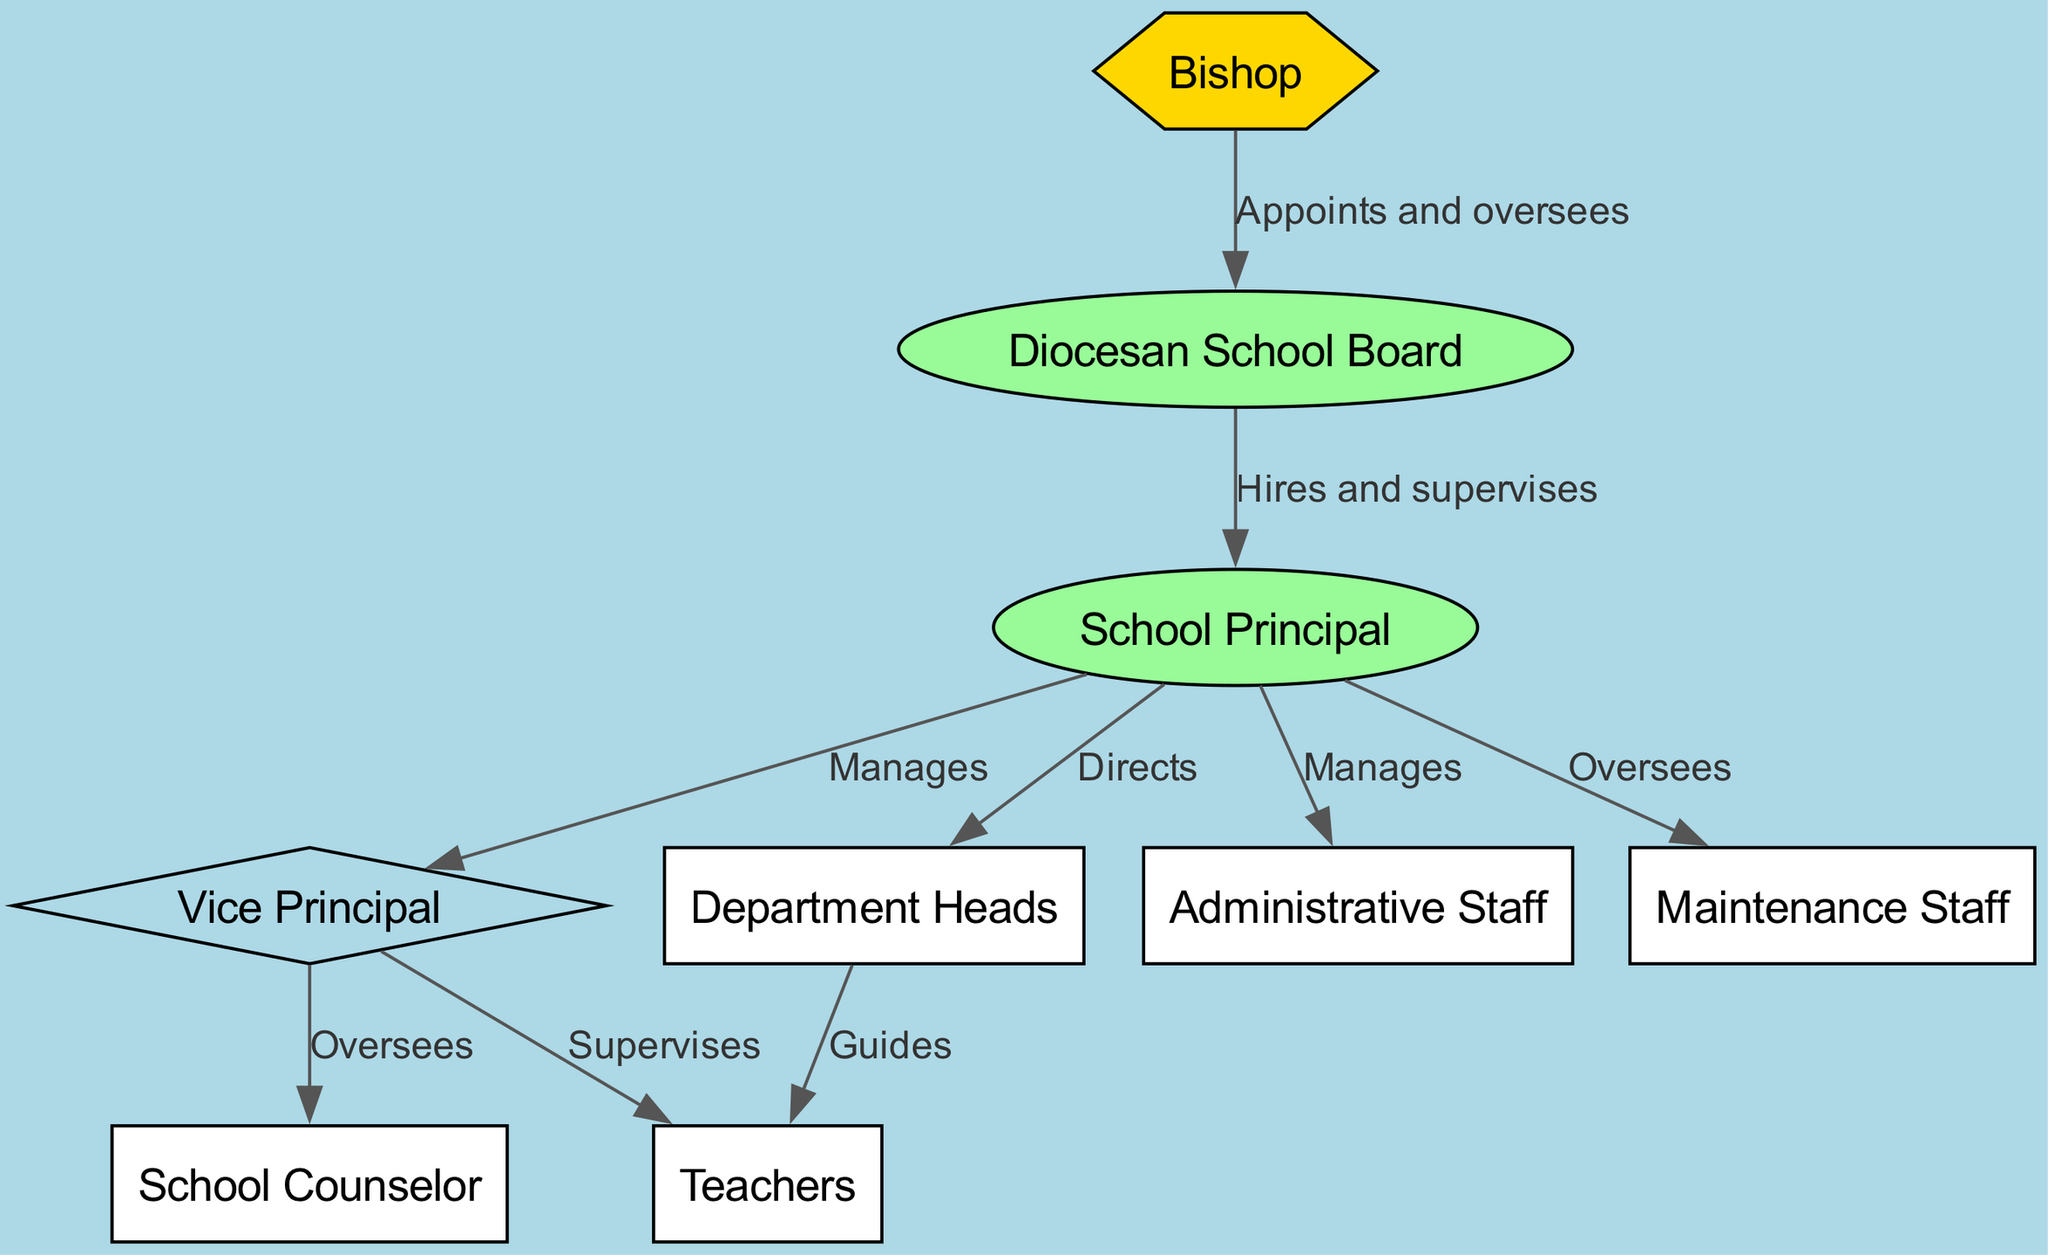What is the top node in the hierarchy? The diagram shows "Bishop" at the top, indicating that the Bishop is the highest authority in the structure. Therefore, "Bishop" is the top node in the hierarchy.
Answer: Bishop How many nodes are present in the diagram? By counting the distinct positions shown, there are a total of 9 unique nodes representing various roles within the Catholic school system. Thus, the answer is 9.
Answer: 9 Who does the Vice Principal supervise? The edges from "Vice Principal" show arrows leading to both "Teachers" and "School Counselor". This means the Vice Principal supervises both of these roles.
Answer: Teachers, School Counselor What is the role of the Diocesan School Board in relation to the School Principal? The arrow from "Diocesan School Board" to "School Principal" is labeled with "Hires and supervises", indicating that this board is responsible for hiring and supervising the School Principal.
Answer: Hires and supervises Which staff members does the School Principal oversee? The diagram shows arrows from "School Principal" to both "Administrative Staff" and "Maintenance Staff", indicating that the School Principal manages these two groups.
Answer: Administrative Staff, Maintenance Staff Who is responsible for guiding the Teachers? The edge from "Department Heads" to "Teachers" shows the label "Guides", indicating that the Department Heads have the responsibility for guiding the Teachers.
Answer: Department Heads What type of node is the Bishop? The diagram categorizes the Bishop using a hexagonal shape, which is distinct from the other shapes used for different roles, thus identifying it as a special type of node in the hierarchy.
Answer: Hexagon How does the Vice Principal relate to the other staff? The Vice Principal oversees both the Teachers and the School Counselor, indicating a supervisory relationship. Additionally, it is also managed by the School Principal, further establishing its place in the hierarchy.
Answer: Supervises Teachers, School Counselor What action does the School Principal perform towards the Department Heads? The directed edge from "School Principal" to "Department Heads" is labeled "Directs", signifying that the School Principal actively directs this group in their functions.
Answer: Directs 